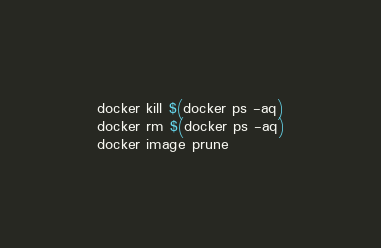Convert code to text. <code><loc_0><loc_0><loc_500><loc_500><_Bash_>docker kill $(docker ps -aq)
docker rm $(docker ps -aq)
docker image prune</code> 